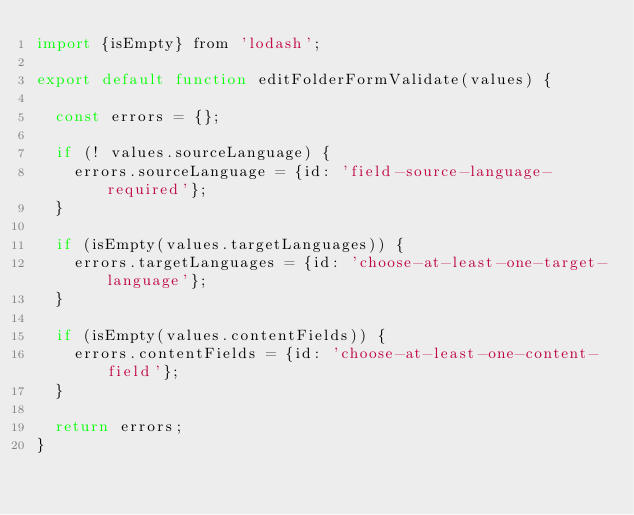<code> <loc_0><loc_0><loc_500><loc_500><_JavaScript_>import {isEmpty} from 'lodash';

export default function editFolderFormValidate(values) {

  const errors = {};

  if (! values.sourceLanguage) {
    errors.sourceLanguage = {id: 'field-source-language-required'};
  }

  if (isEmpty(values.targetLanguages)) {
    errors.targetLanguages = {id: 'choose-at-least-one-target-language'};
  }

  if (isEmpty(values.contentFields)) {
    errors.contentFields = {id: 'choose-at-least-one-content-field'};
  }

  return errors;
}
</code> 